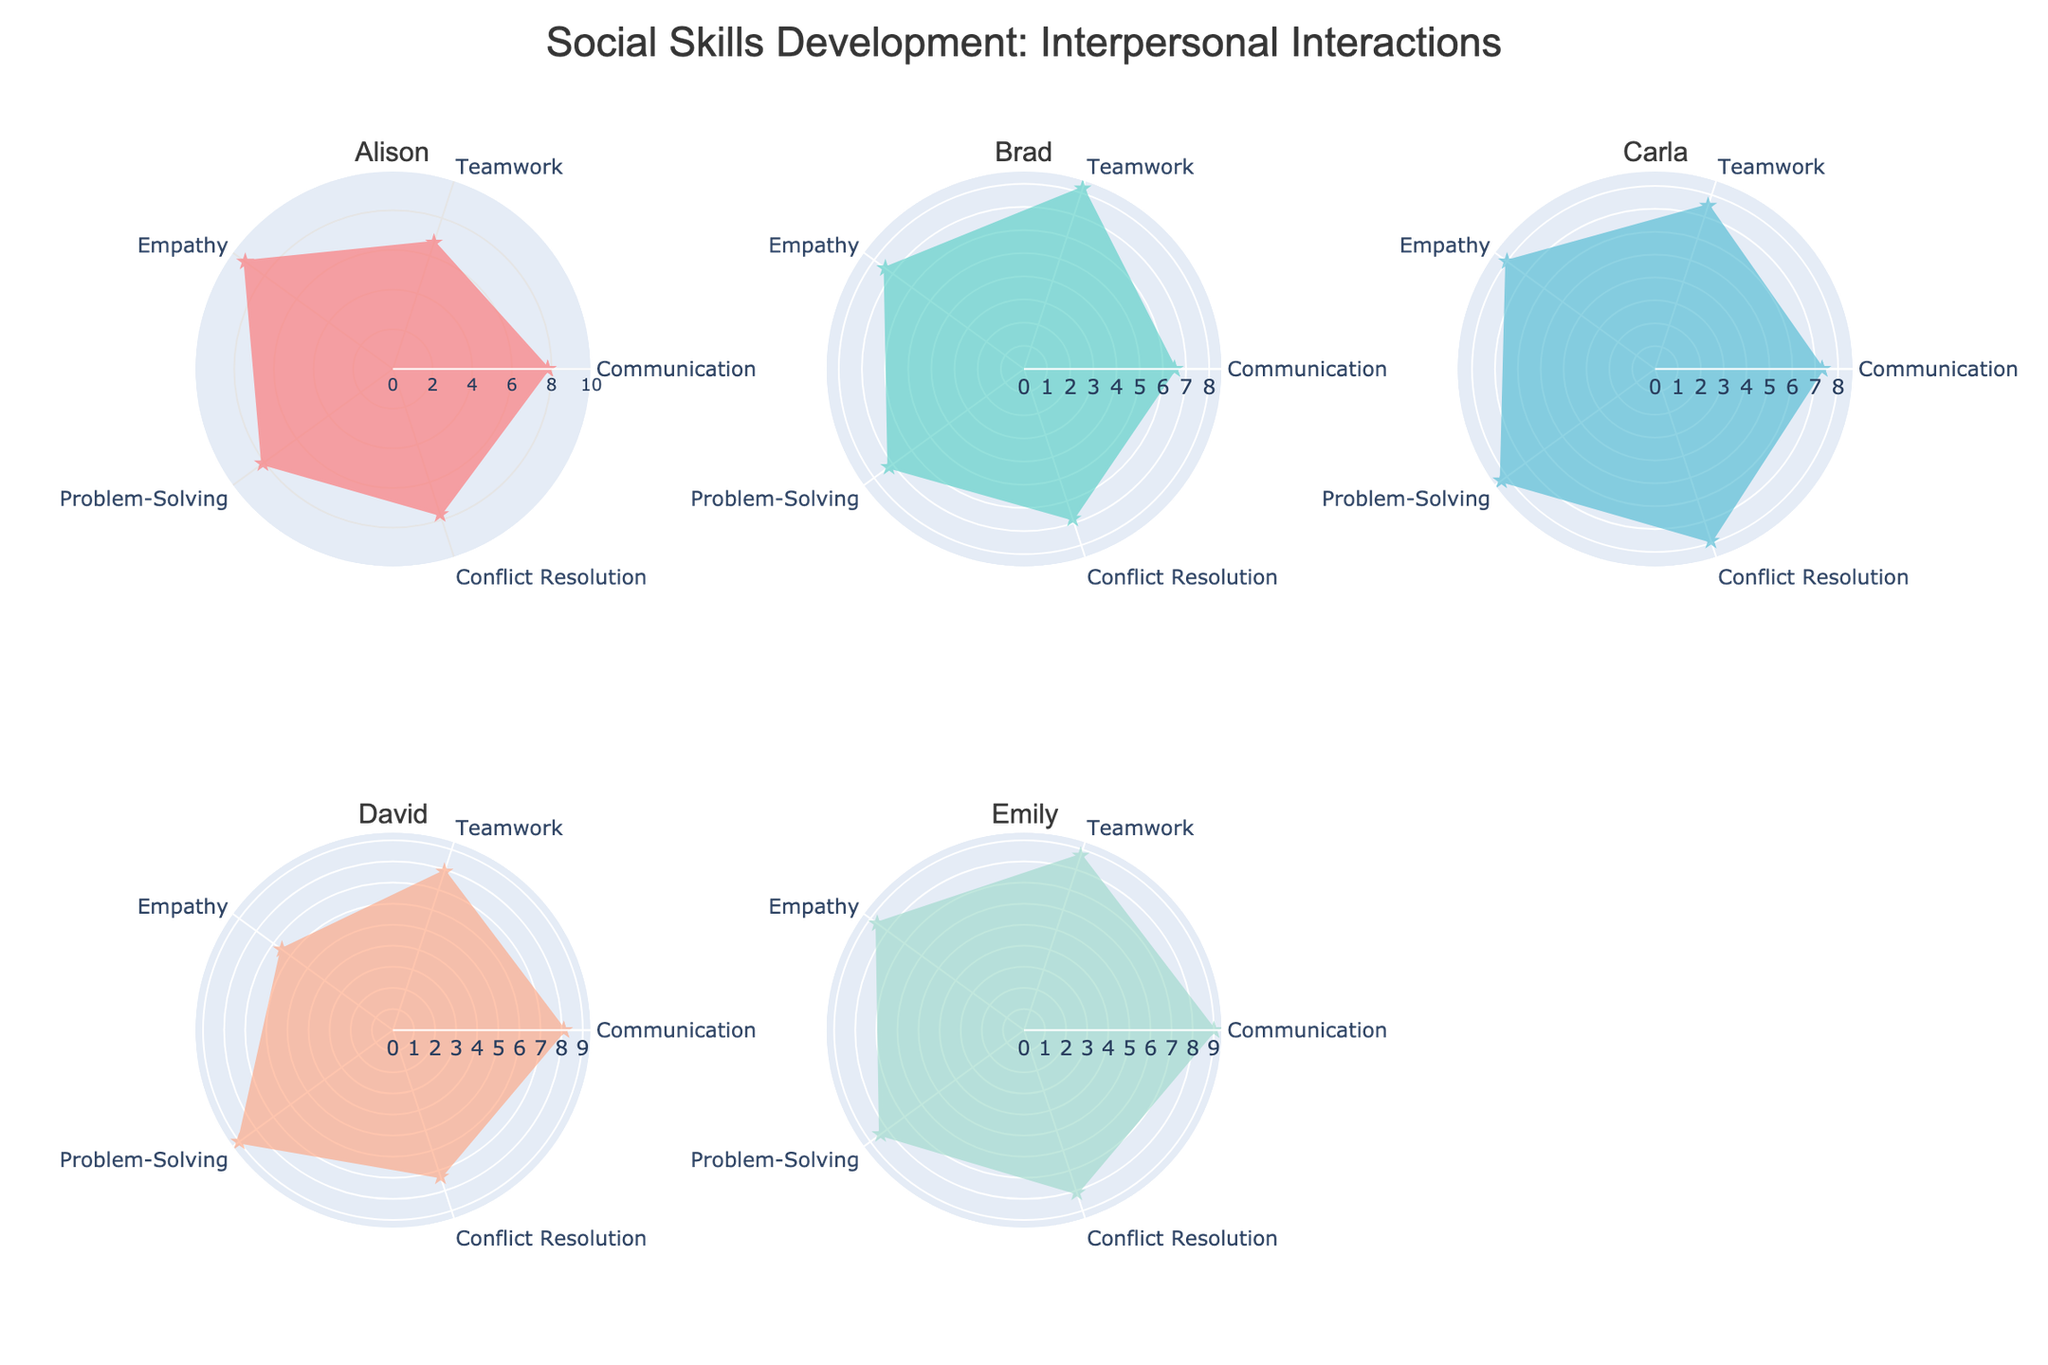What is the title of the plot? The title of the plot is text that generally appears at the top of the figure and provides a summary or main idea of the visualized data. In this case, it's "Social Skills Development: Interpersonal Interactions".
Answer: Social Skills Development: Interpersonal Interactions Which student has the highest value for Communication? To determine the student with the highest value for Communication, compare the Communication scores for Alison, Brad, Carla, David, and Emily. Emily has the highest value in this category with a score of 9.0.
Answer: Emily What is the range of the radial axis in the polar plot? The range of the radial axis in a polar plot specifies the minimum and maximum values that can be represented. Here, the radial axis ranges from 0 to 10.
Answer: 0 to 10 How does Carla's Empathy score compare to David's? Look at Carla and David's Empathy scores. Carla has a score of 8.0, whereas David has a score of 6.5. Thus, Carla’s score is higher.
Answer: Carla's score is higher Which two students are closest in their Teamwork scores? Examine the Teamwork scores for all students: Alison (6.7), Brad (8.2), Carla (7.5), David (7.9), and Emily (8.7). The closest scores are David (7.9) and Carla (7.5), with a difference of 0.4.
Answer: David and Carla Rank the students based on their Problem-Solving scores from highest to lowest. Look at the Problem-Solving scores for all students: Alison (8.1), Brad (7.2), Carla (8.3), David (9.0), and Emily (8.4). Arranged from highest to lowest, they are David (9.0), Emily (8.4), Carla (8.3), Alison (8.1), and Brad (7.2).
Answer: David, Emily, Carla, Alison, Brad What is the average score of Emily across all categories? Calculate the average by adding Emily's scores in all categories and then dividing by the number of categories. Her scores are: Communication (9.0), Teamwork (8.7), Empathy (8.6), Problem-Solving (8.4), and Conflict Resolution (8.1). The sum is 42.8. The average is 42.8/5 = 8.56.
Answer: 8.56 Which student has the most balanced profile across all categories, and how can you tell? The most balanced profile is the one with the least variability in scores across categories. Compare the variances in the scores of each student. Emily's scores range only from 8.1 to 9.0, indicating a high level of balance.
Answer: Emily Which categories have the lowest and highest scores overall, and what are they? For the lowest, compare the lowest scores in each category: Communication (6.5), Teamwork (6.7), Empathy (6.5), Problem-Solving (7.2), Conflict Resolution (6.8). The lowest score overall is in Empathy and Communication: 6.5. For the highest, compare the highest scores in each category: Communication (9.0), Teamwork (8.7), Empathy (9.2), Problem-Solving (9.0), Conflict Resolution (8.1). The highest score overall is in Empathy: 9.2.
Answer: Lowest: Empathy and Communication (6.5), Highest: Empathy (9.2) What is the median score of Brad across all categories? To find the median, list Brad's scores and place them in numerical order: 6.5, 6.8, 7.2, 7.4, 8.2. The median is the middle value in this ordered list, which is 7.2.
Answer: 7.2 